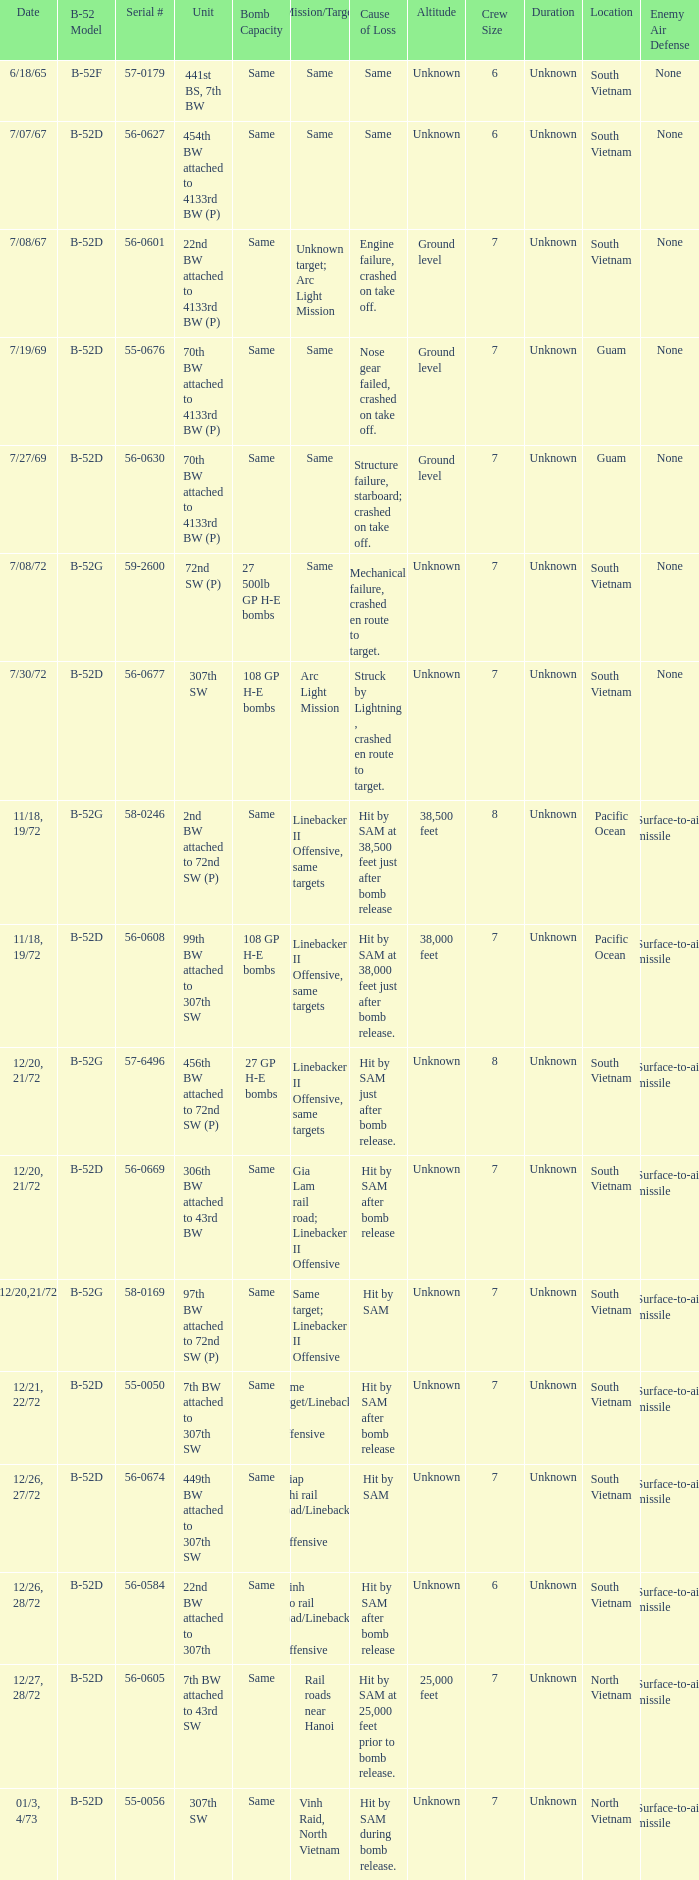When  same target; linebacker ii offensive is the same target what is the unit? 97th BW attached to 72nd SW (P). 